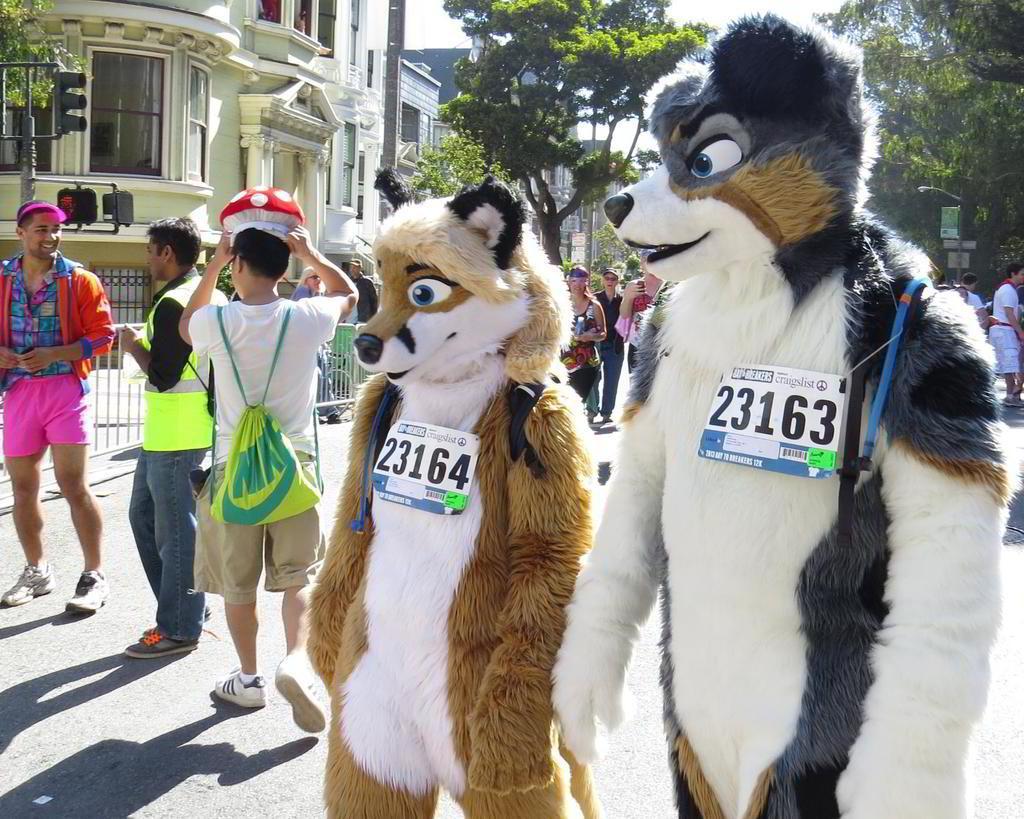Describe this image in one or two sentences. In this image I can see two persons wearing costumes which are white, black and brown in color are standing on the ground. I can see badges attached to them. In the background I can see few other persons standing on the ground, the railing, few buildings, few trees, a traffic signal and the sky. 